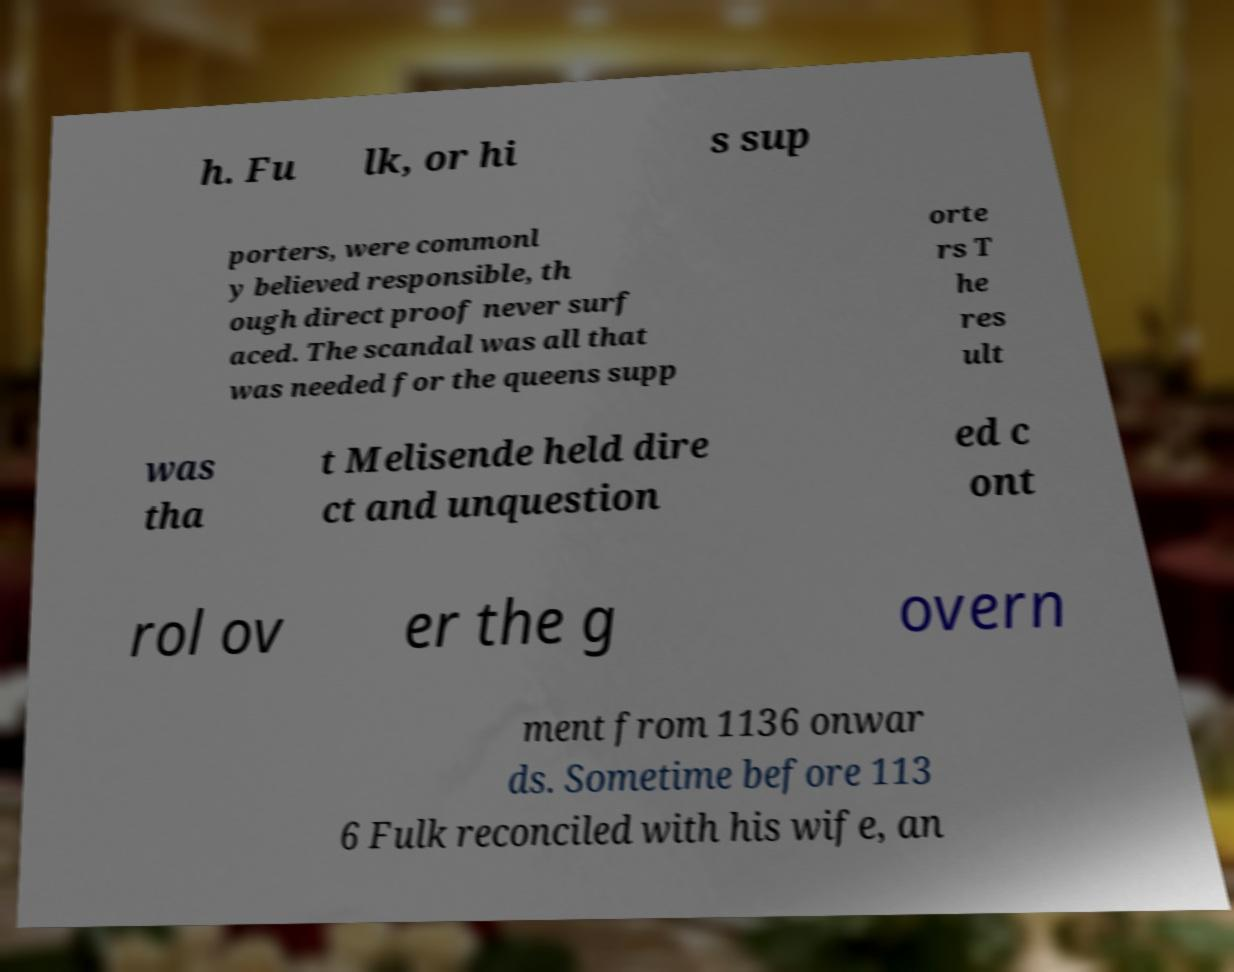Could you assist in decoding the text presented in this image and type it out clearly? h. Fu lk, or hi s sup porters, were commonl y believed responsible, th ough direct proof never surf aced. The scandal was all that was needed for the queens supp orte rs T he res ult was tha t Melisende held dire ct and unquestion ed c ont rol ov er the g overn ment from 1136 onwar ds. Sometime before 113 6 Fulk reconciled with his wife, an 